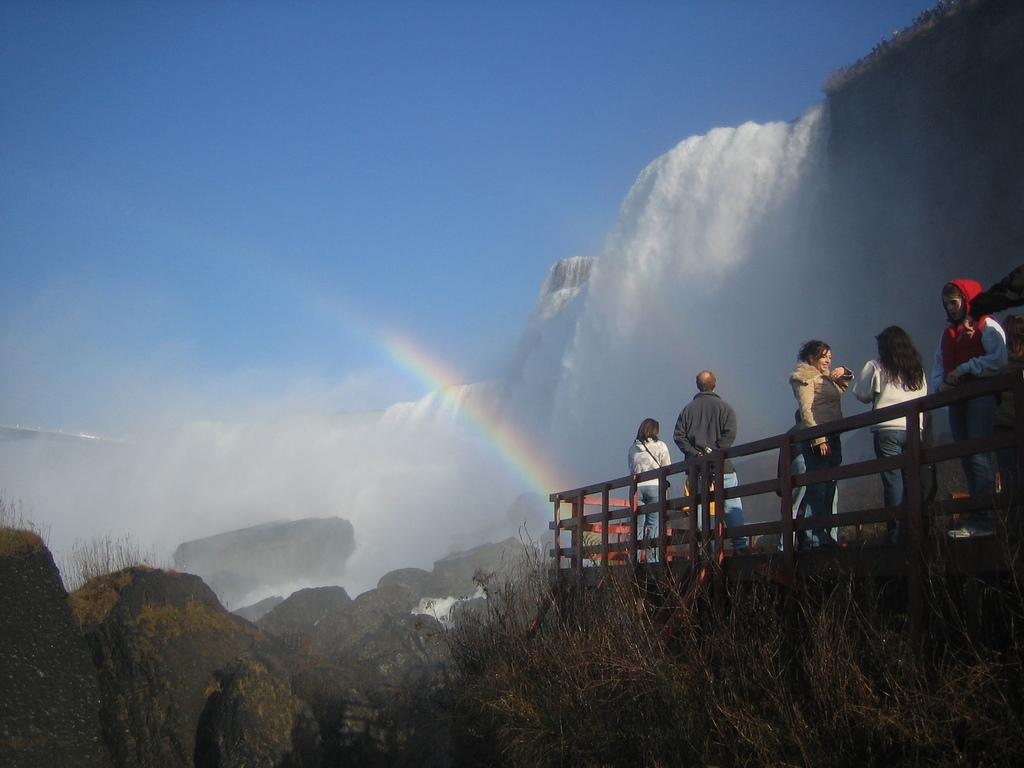What can be seen on the right side of the image? There are people on the right side of the image. What are the people doing in the image? The people are standing in the image. What type of natural elements are near the people? There are plants and rocks near the people. What is the main feature in front of the people? There is a waterfall in front of the people. Can you see any boats in the waterfall in the image? There are no boats present in the image, as it features a waterfall and people standing near plants and rocks. 